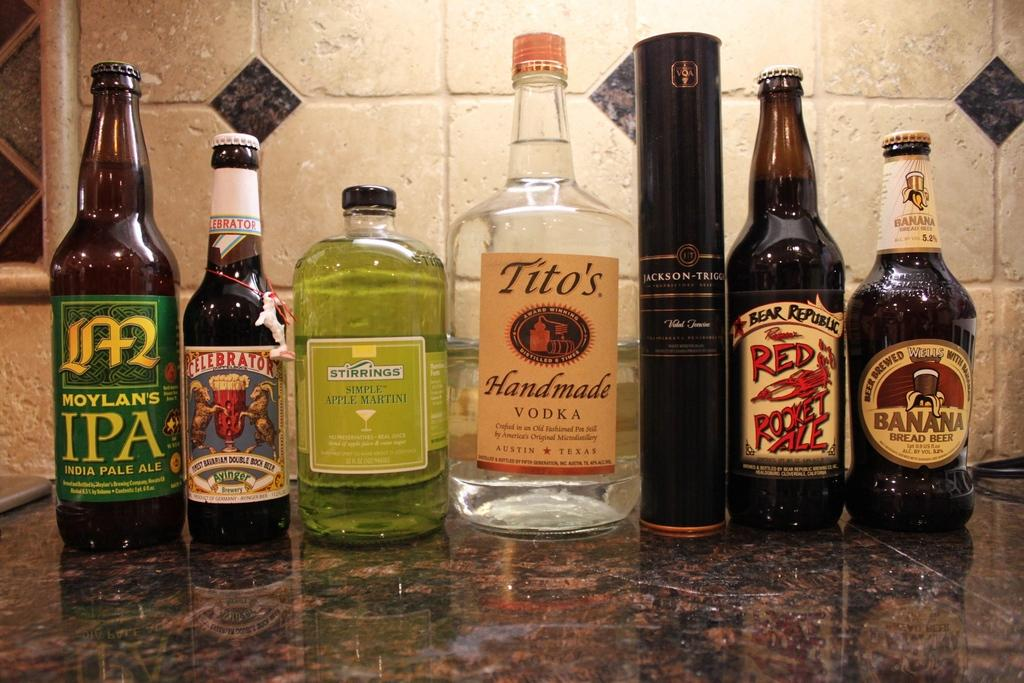Provide a one-sentence caption for the provided image. A row of bottles of beer and vodka and mixer. 